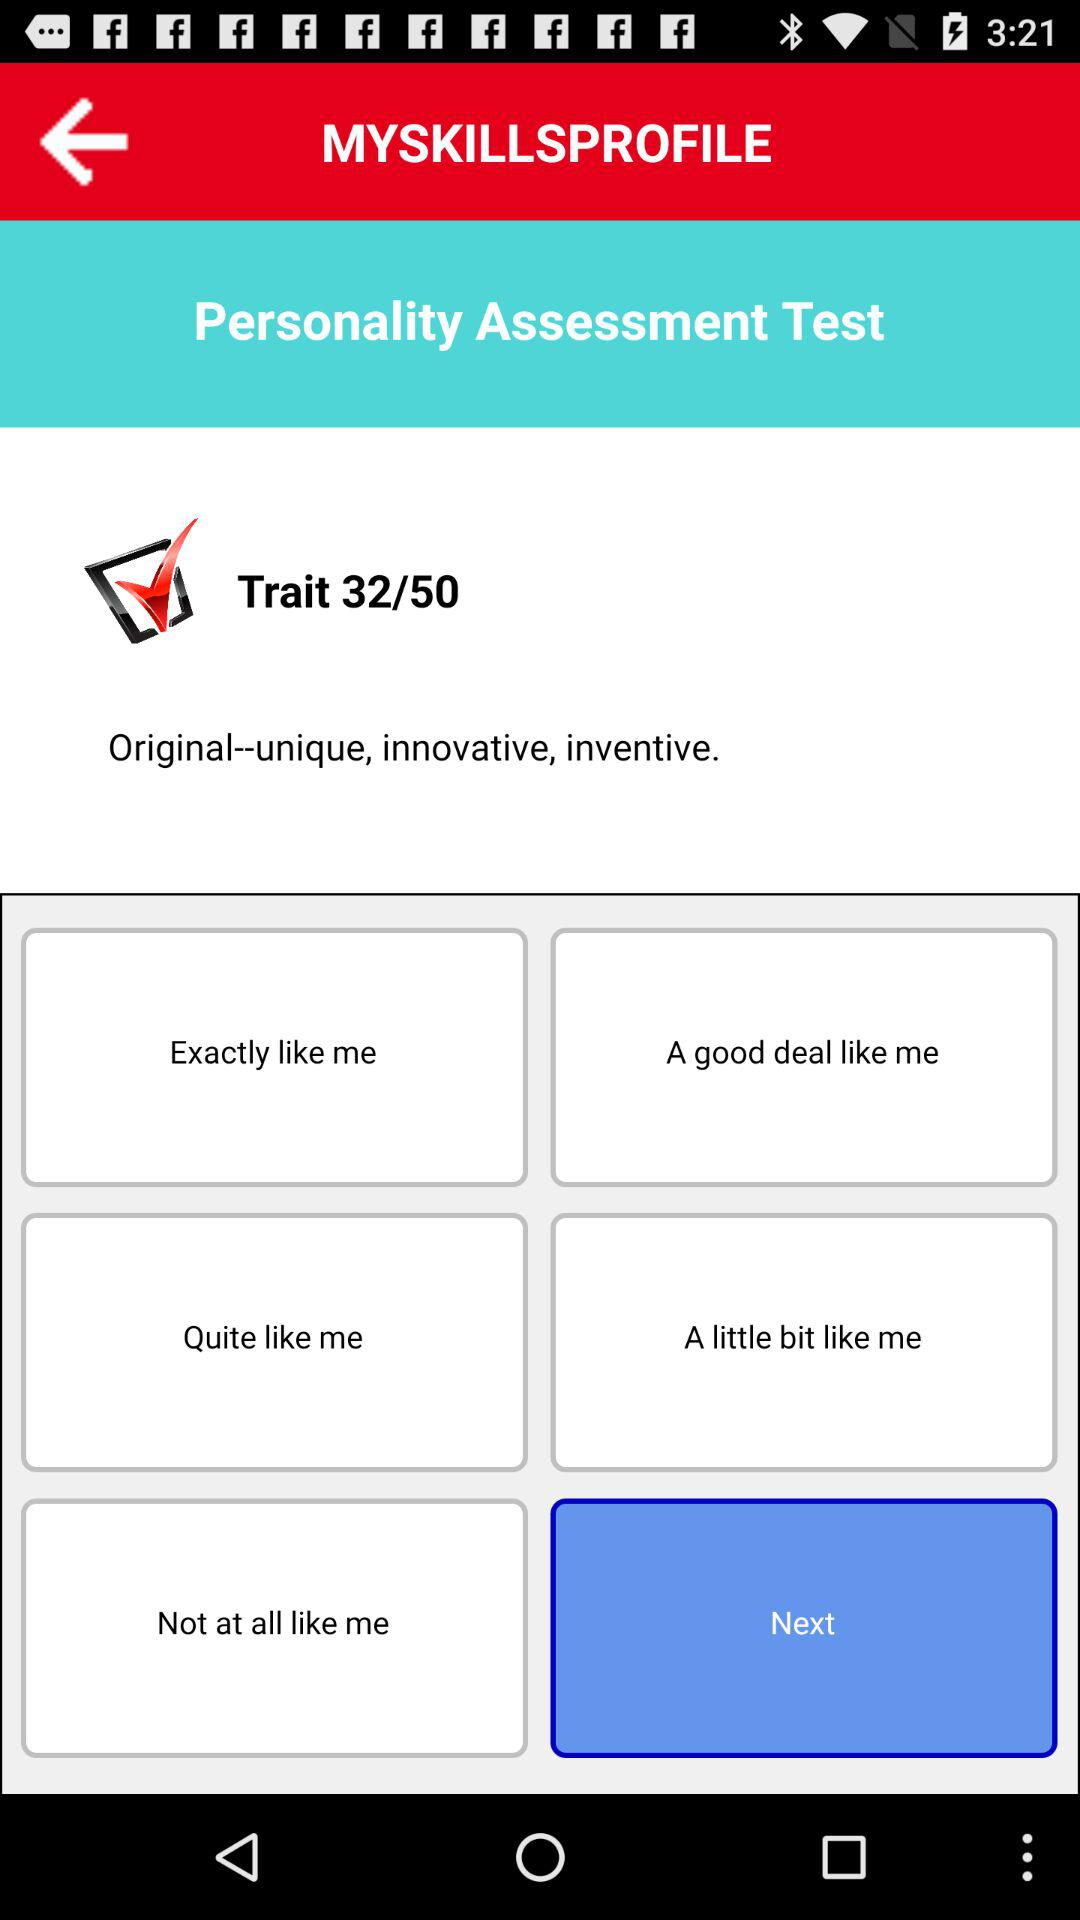On what "Trait" are we currently? You are currently on 32th "Trait". 